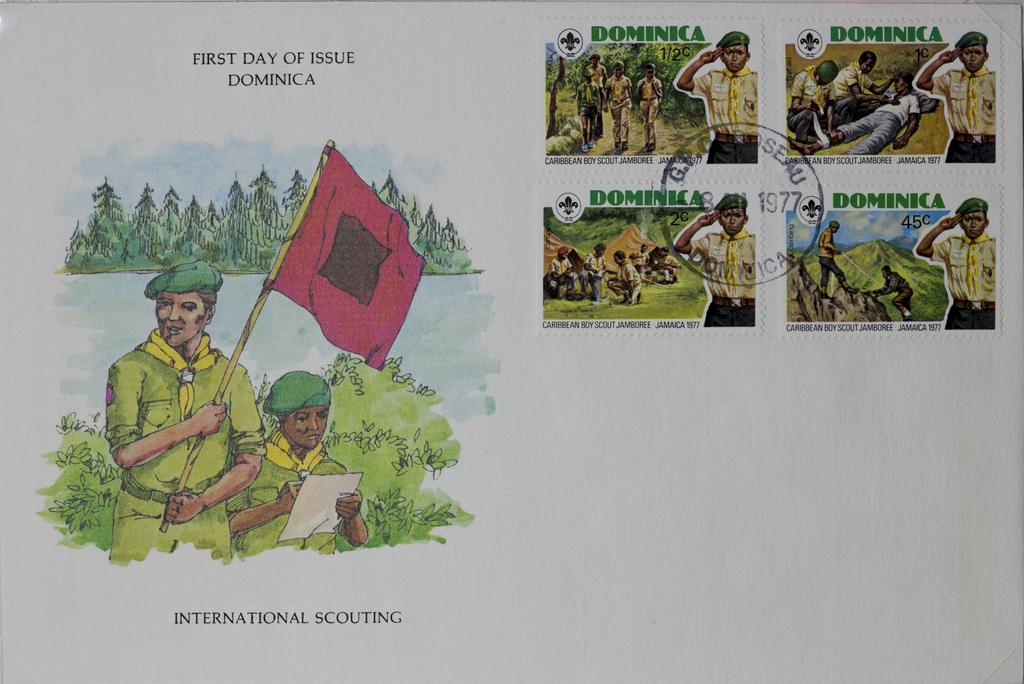<image>
Provide a brief description of the given image. a book that has international scouting in it 